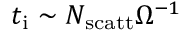Convert formula to latex. <formula><loc_0><loc_0><loc_500><loc_500>t _ { i } \sim N _ { s c a t t } \Omega ^ { - 1 }</formula> 